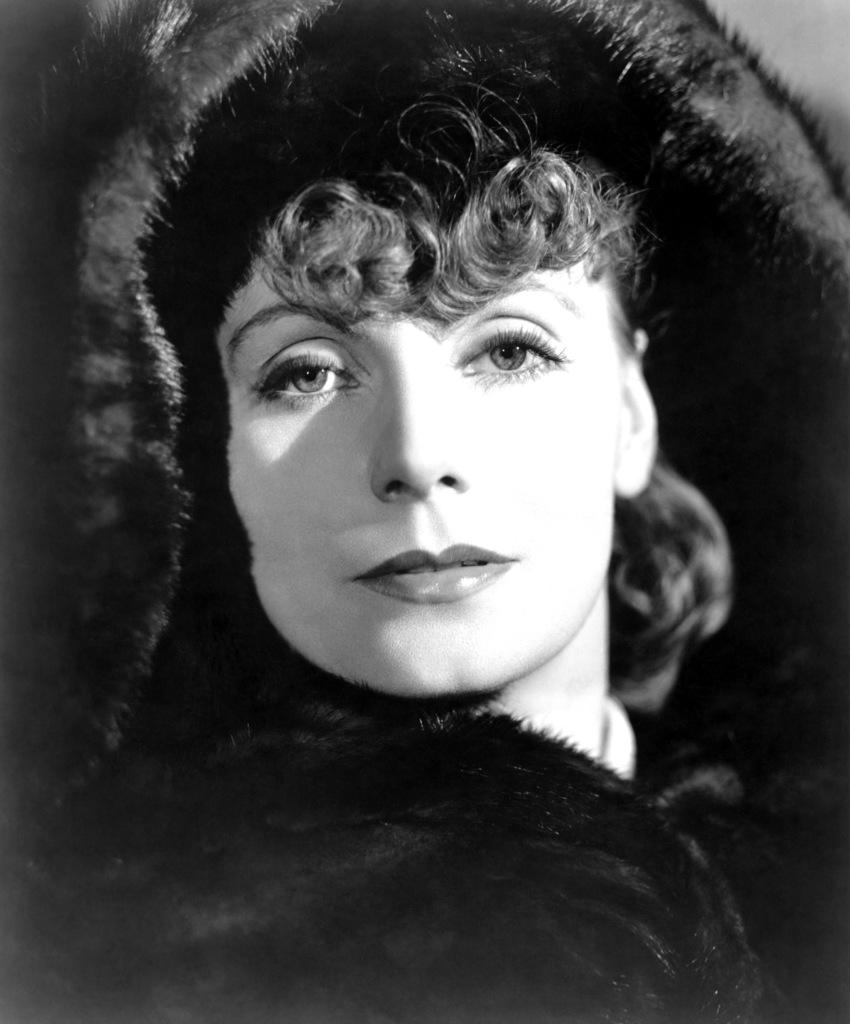Who is present in the image? There is a woman in the image. What place does the woman regret visiting in the image? There is no indication in the image that the woman regrets visiting any place, as the image only shows her presence. 